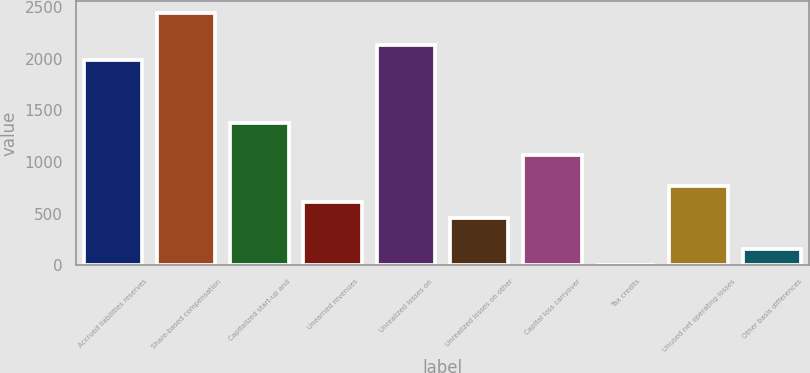Convert chart to OTSL. <chart><loc_0><loc_0><loc_500><loc_500><bar_chart><fcel>Accrued liabilities reserves<fcel>Share-based compensation<fcel>Capitalized start-up and<fcel>Unearned revenues<fcel>Unrealized losses on<fcel>Unrealized losses on other<fcel>Capital loss carryover<fcel>Tax credits<fcel>Unused net operating losses<fcel>Other basis differences<nl><fcel>1984.9<fcel>2441.8<fcel>1375.7<fcel>614.2<fcel>2137.2<fcel>461.9<fcel>1071.1<fcel>5<fcel>766.5<fcel>157.3<nl></chart> 